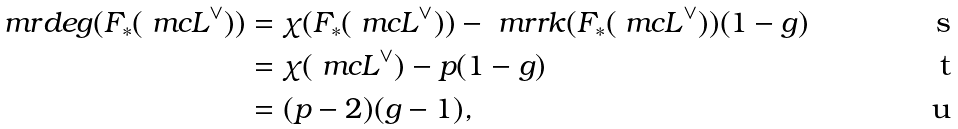Convert formula to latex. <formula><loc_0><loc_0><loc_500><loc_500>\ m r { d e g } ( F _ { * } ( \ m c L ^ { \vee } ) ) = & \ \chi ( F _ { * } ( \ m c L ^ { \vee } ) ) - \ m r { r k } ( F _ { * } ( \ m c L ^ { \vee } ) ) ( 1 - g ) \\ = & \ \chi ( \ m c L ^ { \vee } ) - p ( 1 - g ) \\ = & \ ( p - 2 ) ( g - 1 ) ,</formula> 